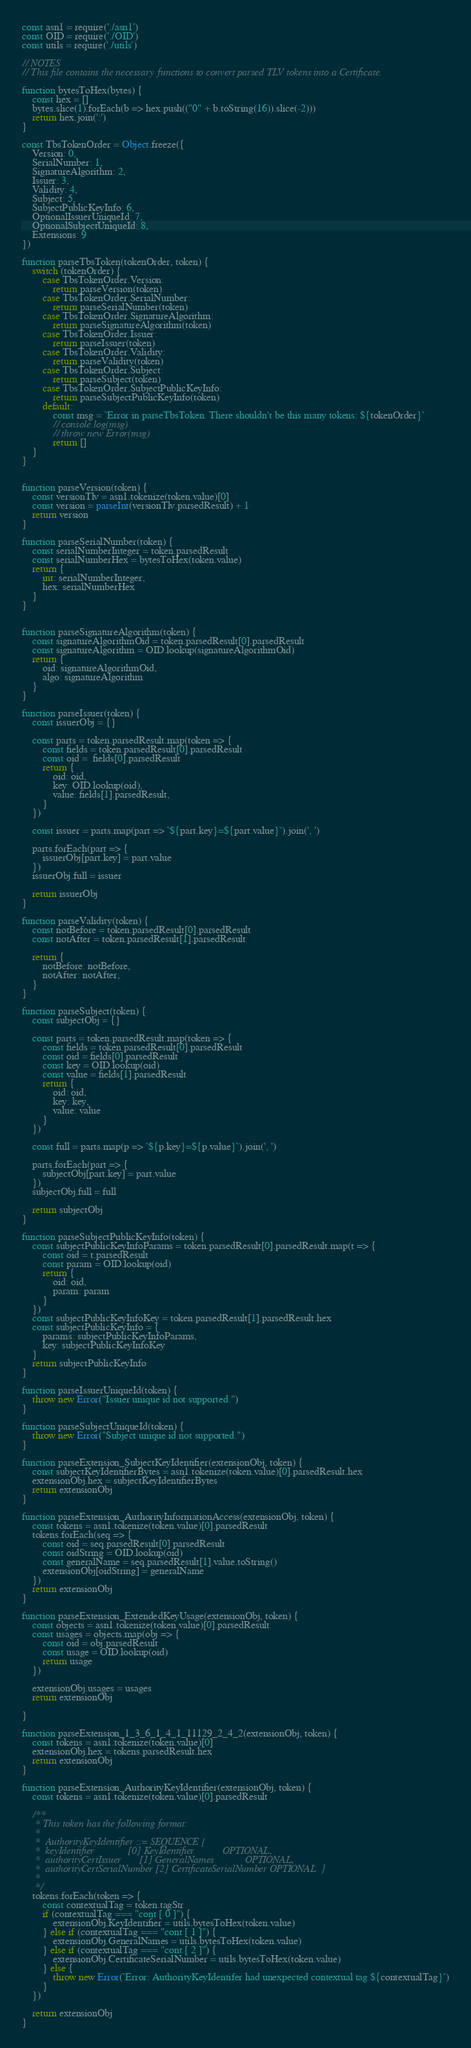<code> <loc_0><loc_0><loc_500><loc_500><_JavaScript_>const asn1 = require('./asn1')
const OID = require('./OID')
const utils = require('./utils')

// NOTES
// This file contains the necessary functions to convert parsed TLV tokens into a Certificate. 

function bytesToHex(bytes) {
    const hex = []
    bytes.slice(1).forEach(b => hex.push(("0" + b.toString(16)).slice(-2)))
    return hex.join(':')
}

const TbsTokenOrder = Object.freeze({
    Version: 0,
    SerialNumber: 1,
    SignatureAlgorithm: 2,
    Issuer: 3,
    Validity: 4,
    Subject: 5,
    SubjectPublicKeyInfo: 6,
    OptionalIssuerUniqueId: 7,
    OptionalSubjectUniqueId: 8,
    Extensions: 9
})

function parseTbsToken(tokenOrder, token) {
    switch (tokenOrder) {
        case TbsTokenOrder.Version:
            return parseVersion(token)
        case TbsTokenOrder.SerialNumber:
            return parseSerialNumber(token)
        case TbsTokenOrder.SignatureAlgorithm:
            return parseSignatureAlgorithm(token)
        case TbsTokenOrder.Issuer:
            return parseIssuer(token)
        case TbsTokenOrder.Validity:
            return parseValidity(token)
        case TbsTokenOrder.Subject:
            return parseSubject(token)
        case TbsTokenOrder.SubjectPublicKeyInfo:
            return parseSubjectPublicKeyInfo(token)
        default:
            const msg = `Error in parseTbsToken. There shouldn't be this many tokens: ${tokenOrder}`
            // console.log(msg)
            // throw new Error(msg)
            return []
    }
}


function parseVersion(token) {
    const versionTlv = asn1.tokenize(token.value)[0]
    const version = parseInt(versionTlv.parsedResult) + 1
    return version
}

function parseSerialNumber(token) {
    const serialNumberInteger = token.parsedResult
    const serialNumberHex = bytesToHex(token.value)
    return {
        int: serialNumberInteger,
        hex: serialNumberHex
    }
}


function parseSignatureAlgorithm(token) {
    const signatureAlgorithmOid = token.parsedResult[0].parsedResult
    const signatureAlgorithm = OID.lookup(signatureAlgorithmOid)
    return {
        oid: signatureAlgorithmOid,
        algo: signatureAlgorithm
    }
}

function parseIssuer(token) {
    const issuerObj = {}

    const parts = token.parsedResult.map(token => {
        const fields = token.parsedResult[0].parsedResult
        const oid =  fields[0].parsedResult
        return {
            oid: oid,
            key: OID.lookup(oid),
            value: fields[1].parsedResult,
        }
    })

    const issuer = parts.map(part => `${part.key}=${part.value}`).join(', ')

    parts.forEach(part => {
        issuerObj[part.key] = part.value
    })
    issuerObj.full = issuer

    return issuerObj
}

function parseValidity(token) {
    const notBefore = token.parsedResult[0].parsedResult
    const notAfter = token.parsedResult[1].parsedResult

    return {
        notBefore: notBefore,
        notAfter: notAfter,
    }
}

function parseSubject(token) {
    const subjectObj = {}

    const parts = token.parsedResult.map(token => {
        const fields = token.parsedResult[0].parsedResult
        const oid = fields[0].parsedResult
        const key = OID.lookup(oid)
        const value = fields[1].parsedResult
        return {
            oid: oid,
            key: key,
            value: value
        }
    })

    const full = parts.map(p => `${p.key}=${p.value}`).join(', ')

    parts.forEach(part => {
        subjectObj[part.key] = part.value
    })
    subjectObj.full = full

    return subjectObj
}

function parseSubjectPublicKeyInfo(token) {
    const subjectPublicKeyInfoParams = token.parsedResult[0].parsedResult.map(t => {
        const oid = t.parsedResult
        const param = OID.lookup(oid)
        return {
            oid: oid,
            param: param
        }
    })
    const subjectPublicKeyInfoKey = token.parsedResult[1].parsedResult.hex
    const subjectPublicKeyInfo = {
        params: subjectPublicKeyInfoParams,
        key: subjectPublicKeyInfoKey
    }
    return subjectPublicKeyInfo
}

function parseIssuerUniqueId(token) {
    throw new Error("Issuer unique id not supported.")
}

function parseSubjectUniqueId(token) {
    throw new Error("Subject unique id not supported.")
}

function parseExtension_SubjectKeyIdentifier(extensionObj, token) {
    const subjectKeyIdentifierBytes = asn1.tokenize(token.value)[0].parsedResult.hex
    extensionObj.hex = subjectKeyIdentifierBytes
    return extensionObj
}

function parseExtension_AuthorityInformationAccess(extensionObj, token) {
    const tokens = asn1.tokenize(token.value)[0].parsedResult
    tokens.forEach(seq => {
        const oid = seq.parsedResult[0].parsedResult
        const oidString = OID.lookup(oid)
        const generalName = seq.parsedResult[1].value.toString()
        extensionObj[oidString] = generalName
    })
    return extensionObj
}

function parseExtension_ExtendedKeyUsage(extensionObj, token) {
    const objects = asn1.tokenize(token.value)[0].parsedResult
    const usages = objects.map(obj => {
        const oid = obj.parsedResult
        const usage = OID.lookup(oid)
        return usage
    })

    extensionObj.usages = usages
    return extensionObj

}

function parseExtension_1_3_6_1_4_1_11129_2_4_2(extensionObj, token) {
    const tokens = asn1.tokenize(token.value)[0]
    extensionObj.hex = tokens.parsedResult.hex
    return extensionObj
}

function parseExtension_AuthorityKeyIdentifier(extensionObj, token) {
    const tokens = asn1.tokenize(token.value)[0].parsedResult

    /**
     * This token has the following format:
     * 
     *  AuthorityKeyIdentifier ::= SEQUENCE {
     *  keyIdentifier             [0] KeyIdentifier           OPTIONAL,
     *  authorityCertIssuer       [1] GeneralNames            OPTIONAL,
     *  authorityCertSerialNumber [2] CertificateSerialNumber OPTIONAL  }
     * 
     */
    tokens.forEach(token => {
        const contextualTag = token.tagStr
        if (contextualTag === "cont [ 0 ]") {
            extensionObj.KeyIdentifier = utils.bytesToHex(token.value)
        } else if (contextualTag === "cont [ 1 ]") {
            extensionObj.GeneralNames = utils.bytesToHex(token.value)
        } else if (contextualTag === "cont [ 2 ]") {
            extensionObj.CertificateSerialNumber = utils.bytesToHex(token.value)
        } else {
            throw new Error(`Error: AuthorityKeyIdentifer had unexpected contextual tag ${contextualTag}`)
        }
    })

    return extensionObj
}
</code> 